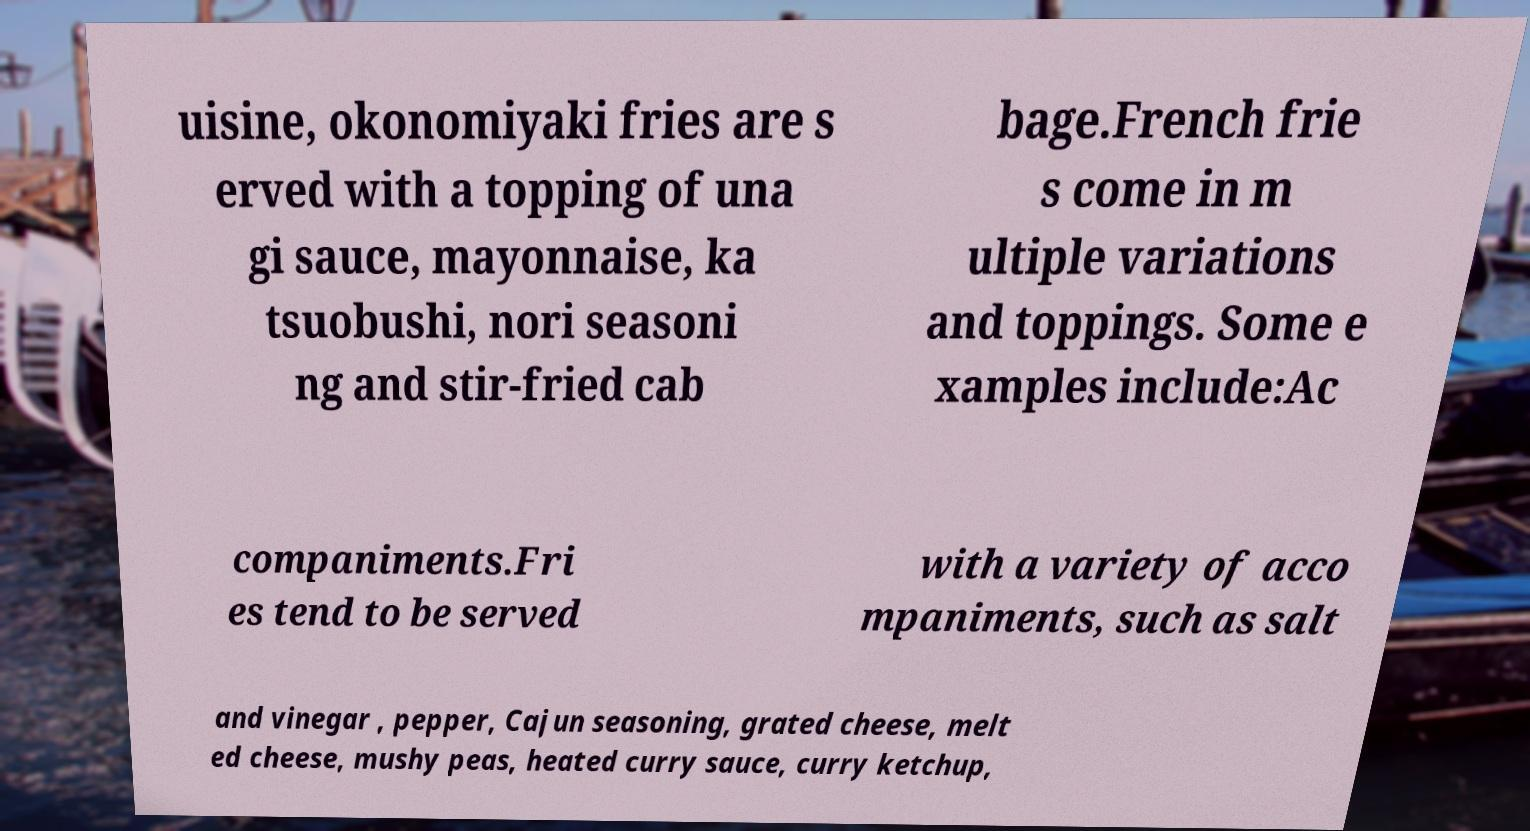Can you read and provide the text displayed in the image?This photo seems to have some interesting text. Can you extract and type it out for me? uisine, okonomiyaki fries are s erved with a topping of una gi sauce, mayonnaise, ka tsuobushi, nori seasoni ng and stir-fried cab bage.French frie s come in m ultiple variations and toppings. Some e xamples include:Ac companiments.Fri es tend to be served with a variety of acco mpaniments, such as salt and vinegar , pepper, Cajun seasoning, grated cheese, melt ed cheese, mushy peas, heated curry sauce, curry ketchup, 